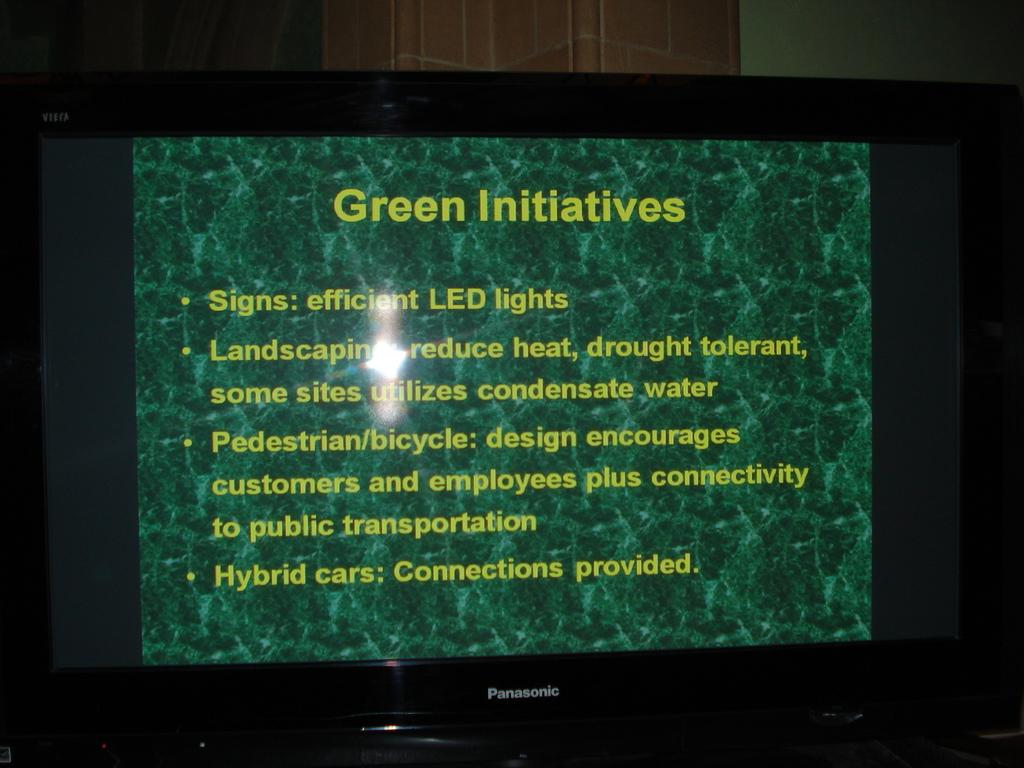<image>
Summarize the visual content of the image. The Panasonic TV is displaying Green Initiatives on the screen. 